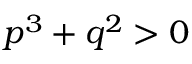Convert formula to latex. <formula><loc_0><loc_0><loc_500><loc_500>p ^ { 3 } + q ^ { 2 } > 0</formula> 